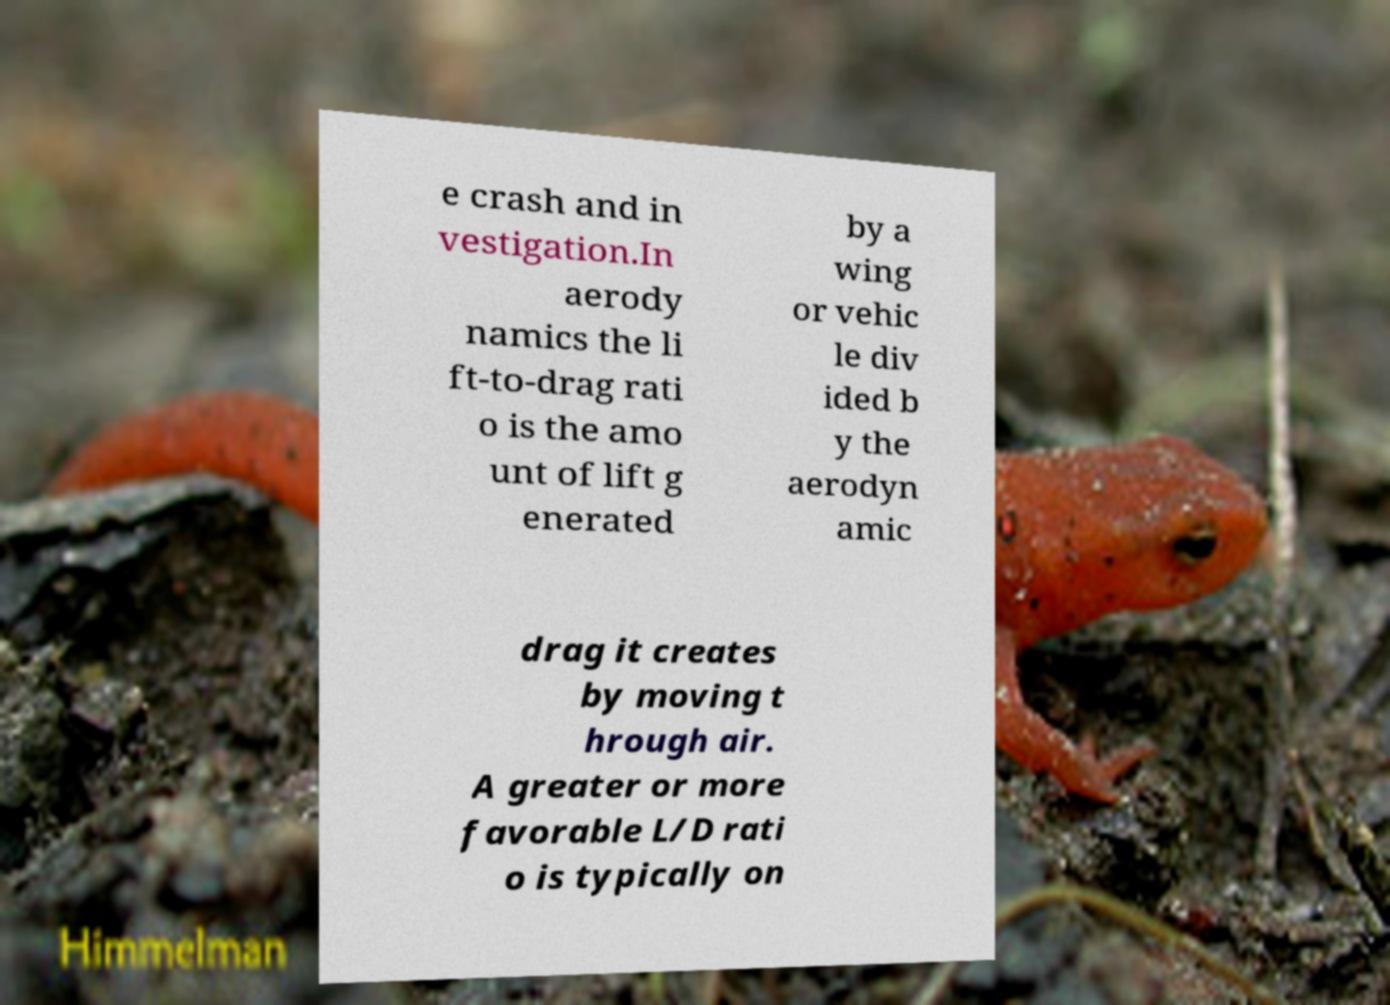Could you assist in decoding the text presented in this image and type it out clearly? e crash and in vestigation.In aerody namics the li ft-to-drag rati o is the amo unt of lift g enerated by a wing or vehic le div ided b y the aerodyn amic drag it creates by moving t hrough air. A greater or more favorable L/D rati o is typically on 